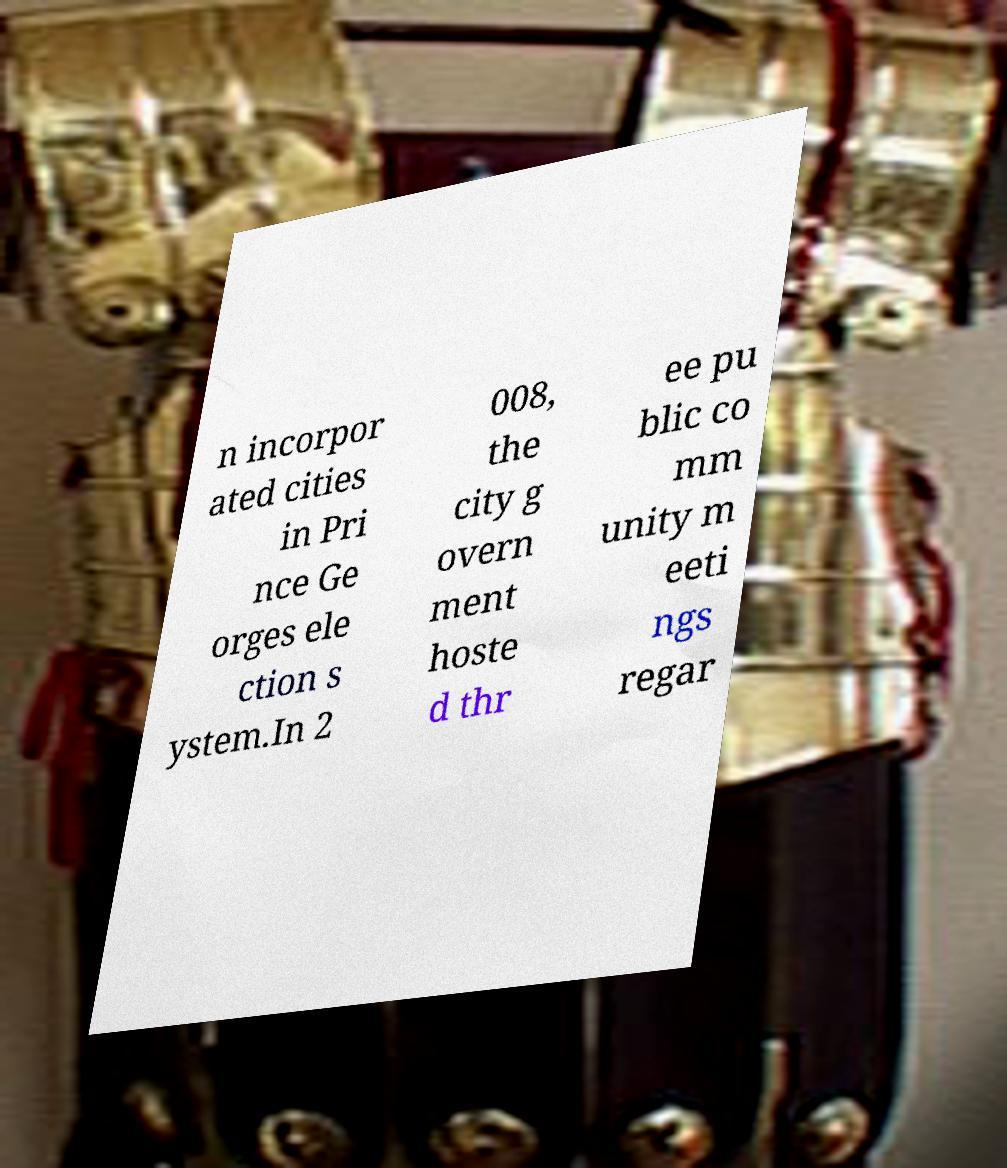Can you accurately transcribe the text from the provided image for me? n incorpor ated cities in Pri nce Ge orges ele ction s ystem.In 2 008, the city g overn ment hoste d thr ee pu blic co mm unity m eeti ngs regar 